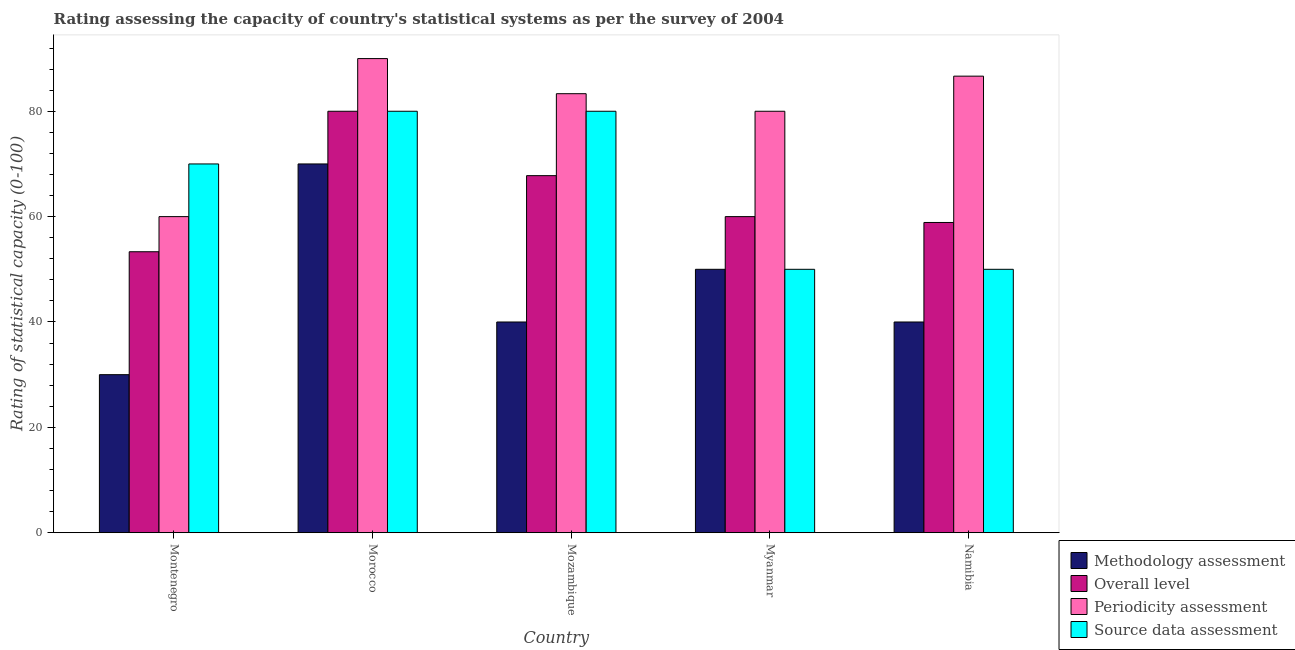How many different coloured bars are there?
Your response must be concise. 4. How many groups of bars are there?
Make the answer very short. 5. Are the number of bars on each tick of the X-axis equal?
Offer a terse response. Yes. How many bars are there on the 1st tick from the left?
Make the answer very short. 4. How many bars are there on the 5th tick from the right?
Make the answer very short. 4. What is the label of the 4th group of bars from the left?
Offer a very short reply. Myanmar. What is the methodology assessment rating in Montenegro?
Offer a terse response. 30. Across all countries, what is the maximum methodology assessment rating?
Give a very brief answer. 70. Across all countries, what is the minimum overall level rating?
Your answer should be compact. 53.33. In which country was the overall level rating maximum?
Offer a very short reply. Morocco. In which country was the overall level rating minimum?
Keep it short and to the point. Montenegro. What is the total periodicity assessment rating in the graph?
Provide a succinct answer. 400. What is the difference between the periodicity assessment rating in Morocco and that in Namibia?
Provide a succinct answer. 3.33. What is the difference between the overall level rating in Myanmar and the periodicity assessment rating in Namibia?
Your answer should be very brief. -26.67. What is the average source data assessment rating per country?
Your response must be concise. 66. In how many countries, is the methodology assessment rating greater than 4 ?
Provide a short and direct response. 5. What is the ratio of the overall level rating in Montenegro to that in Myanmar?
Make the answer very short. 0.89. What is the difference between the highest and the second highest source data assessment rating?
Make the answer very short. 0. In how many countries, is the methodology assessment rating greater than the average methodology assessment rating taken over all countries?
Your answer should be very brief. 2. Is it the case that in every country, the sum of the overall level rating and methodology assessment rating is greater than the sum of source data assessment rating and periodicity assessment rating?
Provide a succinct answer. No. What does the 3rd bar from the left in Montenegro represents?
Make the answer very short. Periodicity assessment. What does the 3rd bar from the right in Myanmar represents?
Your answer should be very brief. Overall level. How many bars are there?
Your answer should be compact. 20. Are all the bars in the graph horizontal?
Give a very brief answer. No. How many countries are there in the graph?
Your answer should be compact. 5. What is the difference between two consecutive major ticks on the Y-axis?
Your response must be concise. 20. Does the graph contain any zero values?
Provide a succinct answer. No. Does the graph contain grids?
Offer a terse response. No. Where does the legend appear in the graph?
Offer a very short reply. Bottom right. How many legend labels are there?
Keep it short and to the point. 4. How are the legend labels stacked?
Ensure brevity in your answer.  Vertical. What is the title of the graph?
Your response must be concise. Rating assessing the capacity of country's statistical systems as per the survey of 2004 . Does "Others" appear as one of the legend labels in the graph?
Give a very brief answer. No. What is the label or title of the Y-axis?
Give a very brief answer. Rating of statistical capacity (0-100). What is the Rating of statistical capacity (0-100) of Methodology assessment in Montenegro?
Keep it short and to the point. 30. What is the Rating of statistical capacity (0-100) of Overall level in Montenegro?
Your response must be concise. 53.33. What is the Rating of statistical capacity (0-100) in Source data assessment in Montenegro?
Your response must be concise. 70. What is the Rating of statistical capacity (0-100) of Methodology assessment in Morocco?
Offer a terse response. 70. What is the Rating of statistical capacity (0-100) in Source data assessment in Morocco?
Make the answer very short. 80. What is the Rating of statistical capacity (0-100) in Methodology assessment in Mozambique?
Ensure brevity in your answer.  40. What is the Rating of statistical capacity (0-100) of Overall level in Mozambique?
Provide a short and direct response. 67.78. What is the Rating of statistical capacity (0-100) in Periodicity assessment in Mozambique?
Ensure brevity in your answer.  83.33. What is the Rating of statistical capacity (0-100) of Source data assessment in Mozambique?
Your answer should be very brief. 80. What is the Rating of statistical capacity (0-100) of Methodology assessment in Myanmar?
Keep it short and to the point. 50. What is the Rating of statistical capacity (0-100) in Overall level in Myanmar?
Provide a succinct answer. 60. What is the Rating of statistical capacity (0-100) in Periodicity assessment in Myanmar?
Offer a very short reply. 80. What is the Rating of statistical capacity (0-100) of Methodology assessment in Namibia?
Make the answer very short. 40. What is the Rating of statistical capacity (0-100) in Overall level in Namibia?
Provide a succinct answer. 58.89. What is the Rating of statistical capacity (0-100) of Periodicity assessment in Namibia?
Keep it short and to the point. 86.67. Across all countries, what is the maximum Rating of statistical capacity (0-100) of Overall level?
Ensure brevity in your answer.  80. Across all countries, what is the maximum Rating of statistical capacity (0-100) of Periodicity assessment?
Provide a short and direct response. 90. Across all countries, what is the minimum Rating of statistical capacity (0-100) in Methodology assessment?
Make the answer very short. 30. Across all countries, what is the minimum Rating of statistical capacity (0-100) of Overall level?
Offer a terse response. 53.33. Across all countries, what is the minimum Rating of statistical capacity (0-100) of Periodicity assessment?
Keep it short and to the point. 60. What is the total Rating of statistical capacity (0-100) in Methodology assessment in the graph?
Give a very brief answer. 230. What is the total Rating of statistical capacity (0-100) of Overall level in the graph?
Your answer should be very brief. 320. What is the total Rating of statistical capacity (0-100) of Periodicity assessment in the graph?
Your answer should be very brief. 400. What is the total Rating of statistical capacity (0-100) in Source data assessment in the graph?
Make the answer very short. 330. What is the difference between the Rating of statistical capacity (0-100) of Overall level in Montenegro and that in Morocco?
Offer a very short reply. -26.67. What is the difference between the Rating of statistical capacity (0-100) in Methodology assessment in Montenegro and that in Mozambique?
Make the answer very short. -10. What is the difference between the Rating of statistical capacity (0-100) of Overall level in Montenegro and that in Mozambique?
Provide a succinct answer. -14.44. What is the difference between the Rating of statistical capacity (0-100) of Periodicity assessment in Montenegro and that in Mozambique?
Provide a succinct answer. -23.33. What is the difference between the Rating of statistical capacity (0-100) of Source data assessment in Montenegro and that in Mozambique?
Give a very brief answer. -10. What is the difference between the Rating of statistical capacity (0-100) in Overall level in Montenegro and that in Myanmar?
Your response must be concise. -6.67. What is the difference between the Rating of statistical capacity (0-100) of Periodicity assessment in Montenegro and that in Myanmar?
Ensure brevity in your answer.  -20. What is the difference between the Rating of statistical capacity (0-100) of Overall level in Montenegro and that in Namibia?
Your answer should be compact. -5.56. What is the difference between the Rating of statistical capacity (0-100) of Periodicity assessment in Montenegro and that in Namibia?
Give a very brief answer. -26.67. What is the difference between the Rating of statistical capacity (0-100) in Source data assessment in Montenegro and that in Namibia?
Offer a terse response. 20. What is the difference between the Rating of statistical capacity (0-100) of Methodology assessment in Morocco and that in Mozambique?
Give a very brief answer. 30. What is the difference between the Rating of statistical capacity (0-100) in Overall level in Morocco and that in Mozambique?
Ensure brevity in your answer.  12.22. What is the difference between the Rating of statistical capacity (0-100) in Overall level in Morocco and that in Myanmar?
Keep it short and to the point. 20. What is the difference between the Rating of statistical capacity (0-100) in Overall level in Morocco and that in Namibia?
Your answer should be compact. 21.11. What is the difference between the Rating of statistical capacity (0-100) in Overall level in Mozambique and that in Myanmar?
Provide a short and direct response. 7.78. What is the difference between the Rating of statistical capacity (0-100) in Source data assessment in Mozambique and that in Myanmar?
Keep it short and to the point. 30. What is the difference between the Rating of statistical capacity (0-100) in Overall level in Mozambique and that in Namibia?
Provide a succinct answer. 8.89. What is the difference between the Rating of statistical capacity (0-100) in Periodicity assessment in Mozambique and that in Namibia?
Make the answer very short. -3.33. What is the difference between the Rating of statistical capacity (0-100) in Methodology assessment in Myanmar and that in Namibia?
Provide a short and direct response. 10. What is the difference between the Rating of statistical capacity (0-100) in Overall level in Myanmar and that in Namibia?
Provide a short and direct response. 1.11. What is the difference between the Rating of statistical capacity (0-100) of Periodicity assessment in Myanmar and that in Namibia?
Your response must be concise. -6.67. What is the difference between the Rating of statistical capacity (0-100) of Source data assessment in Myanmar and that in Namibia?
Keep it short and to the point. 0. What is the difference between the Rating of statistical capacity (0-100) of Methodology assessment in Montenegro and the Rating of statistical capacity (0-100) of Periodicity assessment in Morocco?
Your answer should be compact. -60. What is the difference between the Rating of statistical capacity (0-100) of Methodology assessment in Montenegro and the Rating of statistical capacity (0-100) of Source data assessment in Morocco?
Offer a terse response. -50. What is the difference between the Rating of statistical capacity (0-100) in Overall level in Montenegro and the Rating of statistical capacity (0-100) in Periodicity assessment in Morocco?
Ensure brevity in your answer.  -36.67. What is the difference between the Rating of statistical capacity (0-100) in Overall level in Montenegro and the Rating of statistical capacity (0-100) in Source data assessment in Morocco?
Keep it short and to the point. -26.67. What is the difference between the Rating of statistical capacity (0-100) in Methodology assessment in Montenegro and the Rating of statistical capacity (0-100) in Overall level in Mozambique?
Your answer should be compact. -37.78. What is the difference between the Rating of statistical capacity (0-100) of Methodology assessment in Montenegro and the Rating of statistical capacity (0-100) of Periodicity assessment in Mozambique?
Your response must be concise. -53.33. What is the difference between the Rating of statistical capacity (0-100) of Methodology assessment in Montenegro and the Rating of statistical capacity (0-100) of Source data assessment in Mozambique?
Offer a terse response. -50. What is the difference between the Rating of statistical capacity (0-100) in Overall level in Montenegro and the Rating of statistical capacity (0-100) in Source data assessment in Mozambique?
Keep it short and to the point. -26.67. What is the difference between the Rating of statistical capacity (0-100) of Periodicity assessment in Montenegro and the Rating of statistical capacity (0-100) of Source data assessment in Mozambique?
Provide a succinct answer. -20. What is the difference between the Rating of statistical capacity (0-100) in Methodology assessment in Montenegro and the Rating of statistical capacity (0-100) in Source data assessment in Myanmar?
Your answer should be very brief. -20. What is the difference between the Rating of statistical capacity (0-100) in Overall level in Montenegro and the Rating of statistical capacity (0-100) in Periodicity assessment in Myanmar?
Offer a very short reply. -26.67. What is the difference between the Rating of statistical capacity (0-100) of Overall level in Montenegro and the Rating of statistical capacity (0-100) of Source data assessment in Myanmar?
Provide a short and direct response. 3.33. What is the difference between the Rating of statistical capacity (0-100) of Periodicity assessment in Montenegro and the Rating of statistical capacity (0-100) of Source data assessment in Myanmar?
Provide a succinct answer. 10. What is the difference between the Rating of statistical capacity (0-100) in Methodology assessment in Montenegro and the Rating of statistical capacity (0-100) in Overall level in Namibia?
Your response must be concise. -28.89. What is the difference between the Rating of statistical capacity (0-100) of Methodology assessment in Montenegro and the Rating of statistical capacity (0-100) of Periodicity assessment in Namibia?
Your answer should be compact. -56.67. What is the difference between the Rating of statistical capacity (0-100) of Methodology assessment in Montenegro and the Rating of statistical capacity (0-100) of Source data assessment in Namibia?
Offer a very short reply. -20. What is the difference between the Rating of statistical capacity (0-100) in Overall level in Montenegro and the Rating of statistical capacity (0-100) in Periodicity assessment in Namibia?
Give a very brief answer. -33.33. What is the difference between the Rating of statistical capacity (0-100) in Methodology assessment in Morocco and the Rating of statistical capacity (0-100) in Overall level in Mozambique?
Make the answer very short. 2.22. What is the difference between the Rating of statistical capacity (0-100) in Methodology assessment in Morocco and the Rating of statistical capacity (0-100) in Periodicity assessment in Mozambique?
Provide a short and direct response. -13.33. What is the difference between the Rating of statistical capacity (0-100) in Methodology assessment in Morocco and the Rating of statistical capacity (0-100) in Source data assessment in Myanmar?
Your response must be concise. 20. What is the difference between the Rating of statistical capacity (0-100) in Overall level in Morocco and the Rating of statistical capacity (0-100) in Source data assessment in Myanmar?
Provide a short and direct response. 30. What is the difference between the Rating of statistical capacity (0-100) of Periodicity assessment in Morocco and the Rating of statistical capacity (0-100) of Source data assessment in Myanmar?
Make the answer very short. 40. What is the difference between the Rating of statistical capacity (0-100) of Methodology assessment in Morocco and the Rating of statistical capacity (0-100) of Overall level in Namibia?
Give a very brief answer. 11.11. What is the difference between the Rating of statistical capacity (0-100) in Methodology assessment in Morocco and the Rating of statistical capacity (0-100) in Periodicity assessment in Namibia?
Provide a short and direct response. -16.67. What is the difference between the Rating of statistical capacity (0-100) in Overall level in Morocco and the Rating of statistical capacity (0-100) in Periodicity assessment in Namibia?
Provide a short and direct response. -6.67. What is the difference between the Rating of statistical capacity (0-100) in Methodology assessment in Mozambique and the Rating of statistical capacity (0-100) in Overall level in Myanmar?
Your answer should be very brief. -20. What is the difference between the Rating of statistical capacity (0-100) of Methodology assessment in Mozambique and the Rating of statistical capacity (0-100) of Periodicity assessment in Myanmar?
Make the answer very short. -40. What is the difference between the Rating of statistical capacity (0-100) in Methodology assessment in Mozambique and the Rating of statistical capacity (0-100) in Source data assessment in Myanmar?
Your response must be concise. -10. What is the difference between the Rating of statistical capacity (0-100) in Overall level in Mozambique and the Rating of statistical capacity (0-100) in Periodicity assessment in Myanmar?
Your answer should be compact. -12.22. What is the difference between the Rating of statistical capacity (0-100) in Overall level in Mozambique and the Rating of statistical capacity (0-100) in Source data assessment in Myanmar?
Keep it short and to the point. 17.78. What is the difference between the Rating of statistical capacity (0-100) of Periodicity assessment in Mozambique and the Rating of statistical capacity (0-100) of Source data assessment in Myanmar?
Your answer should be compact. 33.33. What is the difference between the Rating of statistical capacity (0-100) in Methodology assessment in Mozambique and the Rating of statistical capacity (0-100) in Overall level in Namibia?
Make the answer very short. -18.89. What is the difference between the Rating of statistical capacity (0-100) of Methodology assessment in Mozambique and the Rating of statistical capacity (0-100) of Periodicity assessment in Namibia?
Give a very brief answer. -46.67. What is the difference between the Rating of statistical capacity (0-100) in Methodology assessment in Mozambique and the Rating of statistical capacity (0-100) in Source data assessment in Namibia?
Provide a short and direct response. -10. What is the difference between the Rating of statistical capacity (0-100) of Overall level in Mozambique and the Rating of statistical capacity (0-100) of Periodicity assessment in Namibia?
Your answer should be very brief. -18.89. What is the difference between the Rating of statistical capacity (0-100) in Overall level in Mozambique and the Rating of statistical capacity (0-100) in Source data assessment in Namibia?
Your answer should be very brief. 17.78. What is the difference between the Rating of statistical capacity (0-100) of Periodicity assessment in Mozambique and the Rating of statistical capacity (0-100) of Source data assessment in Namibia?
Your response must be concise. 33.33. What is the difference between the Rating of statistical capacity (0-100) in Methodology assessment in Myanmar and the Rating of statistical capacity (0-100) in Overall level in Namibia?
Your answer should be compact. -8.89. What is the difference between the Rating of statistical capacity (0-100) in Methodology assessment in Myanmar and the Rating of statistical capacity (0-100) in Periodicity assessment in Namibia?
Offer a terse response. -36.67. What is the difference between the Rating of statistical capacity (0-100) of Overall level in Myanmar and the Rating of statistical capacity (0-100) of Periodicity assessment in Namibia?
Provide a succinct answer. -26.67. What is the difference between the Rating of statistical capacity (0-100) of Periodicity assessment in Myanmar and the Rating of statistical capacity (0-100) of Source data assessment in Namibia?
Provide a short and direct response. 30. What is the average Rating of statistical capacity (0-100) in Methodology assessment per country?
Your answer should be very brief. 46. What is the average Rating of statistical capacity (0-100) in Overall level per country?
Offer a terse response. 64. What is the difference between the Rating of statistical capacity (0-100) in Methodology assessment and Rating of statistical capacity (0-100) in Overall level in Montenegro?
Ensure brevity in your answer.  -23.33. What is the difference between the Rating of statistical capacity (0-100) of Methodology assessment and Rating of statistical capacity (0-100) of Periodicity assessment in Montenegro?
Ensure brevity in your answer.  -30. What is the difference between the Rating of statistical capacity (0-100) in Overall level and Rating of statistical capacity (0-100) in Periodicity assessment in Montenegro?
Your response must be concise. -6.67. What is the difference between the Rating of statistical capacity (0-100) in Overall level and Rating of statistical capacity (0-100) in Source data assessment in Montenegro?
Ensure brevity in your answer.  -16.67. What is the difference between the Rating of statistical capacity (0-100) of Periodicity assessment and Rating of statistical capacity (0-100) of Source data assessment in Montenegro?
Offer a terse response. -10. What is the difference between the Rating of statistical capacity (0-100) in Methodology assessment and Rating of statistical capacity (0-100) in Periodicity assessment in Morocco?
Make the answer very short. -20. What is the difference between the Rating of statistical capacity (0-100) of Methodology assessment and Rating of statistical capacity (0-100) of Source data assessment in Morocco?
Your answer should be very brief. -10. What is the difference between the Rating of statistical capacity (0-100) in Overall level and Rating of statistical capacity (0-100) in Source data assessment in Morocco?
Offer a terse response. 0. What is the difference between the Rating of statistical capacity (0-100) of Periodicity assessment and Rating of statistical capacity (0-100) of Source data assessment in Morocco?
Provide a succinct answer. 10. What is the difference between the Rating of statistical capacity (0-100) of Methodology assessment and Rating of statistical capacity (0-100) of Overall level in Mozambique?
Your answer should be compact. -27.78. What is the difference between the Rating of statistical capacity (0-100) in Methodology assessment and Rating of statistical capacity (0-100) in Periodicity assessment in Mozambique?
Offer a very short reply. -43.33. What is the difference between the Rating of statistical capacity (0-100) of Overall level and Rating of statistical capacity (0-100) of Periodicity assessment in Mozambique?
Your answer should be compact. -15.56. What is the difference between the Rating of statistical capacity (0-100) of Overall level and Rating of statistical capacity (0-100) of Source data assessment in Mozambique?
Your answer should be very brief. -12.22. What is the difference between the Rating of statistical capacity (0-100) of Methodology assessment and Rating of statistical capacity (0-100) of Overall level in Myanmar?
Your answer should be compact. -10. What is the difference between the Rating of statistical capacity (0-100) of Methodology assessment and Rating of statistical capacity (0-100) of Periodicity assessment in Myanmar?
Your answer should be compact. -30. What is the difference between the Rating of statistical capacity (0-100) of Methodology assessment and Rating of statistical capacity (0-100) of Source data assessment in Myanmar?
Ensure brevity in your answer.  0. What is the difference between the Rating of statistical capacity (0-100) in Overall level and Rating of statistical capacity (0-100) in Periodicity assessment in Myanmar?
Provide a short and direct response. -20. What is the difference between the Rating of statistical capacity (0-100) of Methodology assessment and Rating of statistical capacity (0-100) of Overall level in Namibia?
Ensure brevity in your answer.  -18.89. What is the difference between the Rating of statistical capacity (0-100) in Methodology assessment and Rating of statistical capacity (0-100) in Periodicity assessment in Namibia?
Give a very brief answer. -46.67. What is the difference between the Rating of statistical capacity (0-100) of Overall level and Rating of statistical capacity (0-100) of Periodicity assessment in Namibia?
Give a very brief answer. -27.78. What is the difference between the Rating of statistical capacity (0-100) in Overall level and Rating of statistical capacity (0-100) in Source data assessment in Namibia?
Your answer should be compact. 8.89. What is the difference between the Rating of statistical capacity (0-100) of Periodicity assessment and Rating of statistical capacity (0-100) of Source data assessment in Namibia?
Give a very brief answer. 36.67. What is the ratio of the Rating of statistical capacity (0-100) of Methodology assessment in Montenegro to that in Morocco?
Ensure brevity in your answer.  0.43. What is the ratio of the Rating of statistical capacity (0-100) in Overall level in Montenegro to that in Morocco?
Offer a terse response. 0.67. What is the ratio of the Rating of statistical capacity (0-100) of Periodicity assessment in Montenegro to that in Morocco?
Keep it short and to the point. 0.67. What is the ratio of the Rating of statistical capacity (0-100) of Overall level in Montenegro to that in Mozambique?
Provide a short and direct response. 0.79. What is the ratio of the Rating of statistical capacity (0-100) in Periodicity assessment in Montenegro to that in Mozambique?
Offer a very short reply. 0.72. What is the ratio of the Rating of statistical capacity (0-100) of Overall level in Montenegro to that in Myanmar?
Ensure brevity in your answer.  0.89. What is the ratio of the Rating of statistical capacity (0-100) of Periodicity assessment in Montenegro to that in Myanmar?
Give a very brief answer. 0.75. What is the ratio of the Rating of statistical capacity (0-100) of Source data assessment in Montenegro to that in Myanmar?
Make the answer very short. 1.4. What is the ratio of the Rating of statistical capacity (0-100) of Overall level in Montenegro to that in Namibia?
Your answer should be compact. 0.91. What is the ratio of the Rating of statistical capacity (0-100) in Periodicity assessment in Montenegro to that in Namibia?
Provide a short and direct response. 0.69. What is the ratio of the Rating of statistical capacity (0-100) of Methodology assessment in Morocco to that in Mozambique?
Provide a short and direct response. 1.75. What is the ratio of the Rating of statistical capacity (0-100) of Overall level in Morocco to that in Mozambique?
Your answer should be very brief. 1.18. What is the ratio of the Rating of statistical capacity (0-100) of Source data assessment in Morocco to that in Mozambique?
Give a very brief answer. 1. What is the ratio of the Rating of statistical capacity (0-100) in Methodology assessment in Morocco to that in Myanmar?
Give a very brief answer. 1.4. What is the ratio of the Rating of statistical capacity (0-100) in Periodicity assessment in Morocco to that in Myanmar?
Provide a succinct answer. 1.12. What is the ratio of the Rating of statistical capacity (0-100) of Source data assessment in Morocco to that in Myanmar?
Your answer should be compact. 1.6. What is the ratio of the Rating of statistical capacity (0-100) of Methodology assessment in Morocco to that in Namibia?
Your answer should be very brief. 1.75. What is the ratio of the Rating of statistical capacity (0-100) of Overall level in Morocco to that in Namibia?
Make the answer very short. 1.36. What is the ratio of the Rating of statistical capacity (0-100) of Periodicity assessment in Morocco to that in Namibia?
Offer a terse response. 1.04. What is the ratio of the Rating of statistical capacity (0-100) of Source data assessment in Morocco to that in Namibia?
Your answer should be very brief. 1.6. What is the ratio of the Rating of statistical capacity (0-100) of Overall level in Mozambique to that in Myanmar?
Your response must be concise. 1.13. What is the ratio of the Rating of statistical capacity (0-100) of Periodicity assessment in Mozambique to that in Myanmar?
Your answer should be compact. 1.04. What is the ratio of the Rating of statistical capacity (0-100) of Overall level in Mozambique to that in Namibia?
Ensure brevity in your answer.  1.15. What is the ratio of the Rating of statistical capacity (0-100) in Periodicity assessment in Mozambique to that in Namibia?
Your answer should be compact. 0.96. What is the ratio of the Rating of statistical capacity (0-100) of Source data assessment in Mozambique to that in Namibia?
Make the answer very short. 1.6. What is the ratio of the Rating of statistical capacity (0-100) in Overall level in Myanmar to that in Namibia?
Ensure brevity in your answer.  1.02. What is the ratio of the Rating of statistical capacity (0-100) of Periodicity assessment in Myanmar to that in Namibia?
Offer a very short reply. 0.92. What is the difference between the highest and the second highest Rating of statistical capacity (0-100) in Overall level?
Provide a succinct answer. 12.22. What is the difference between the highest and the second highest Rating of statistical capacity (0-100) in Periodicity assessment?
Offer a terse response. 3.33. What is the difference between the highest and the lowest Rating of statistical capacity (0-100) of Overall level?
Offer a terse response. 26.67. What is the difference between the highest and the lowest Rating of statistical capacity (0-100) in Source data assessment?
Make the answer very short. 30. 